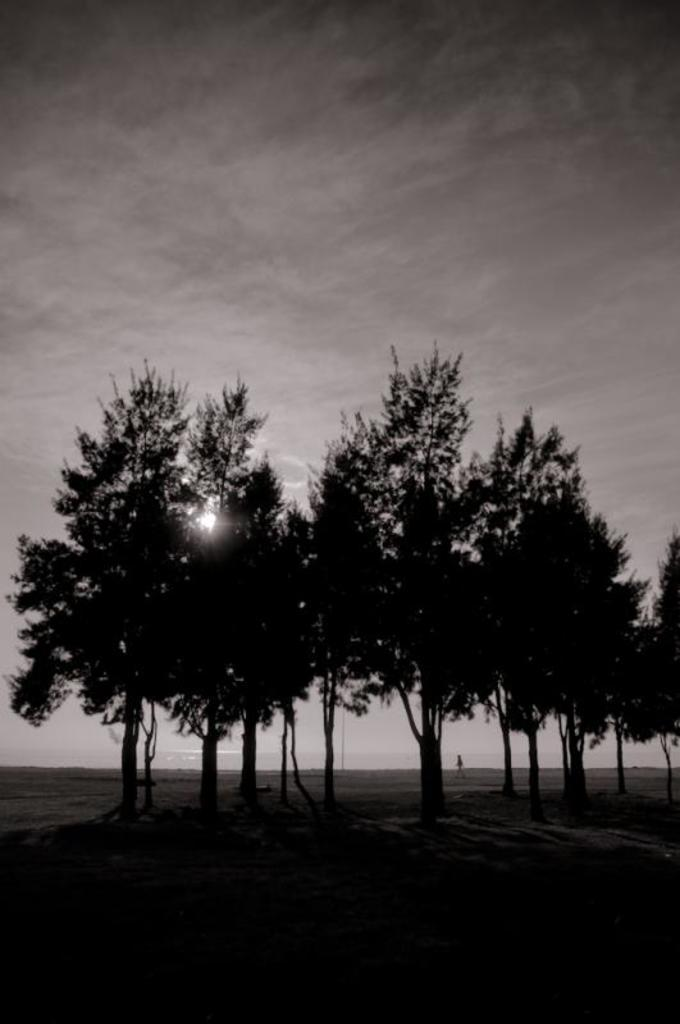What type of vegetation is present in the image? There are trees in the image. What part of the natural environment is visible in the image? The sky is visible at the top of the image. Can you describe the lighting conditions in the image? The image appears to be slightly dark. What type of apparel is the bee wearing in the image? There is no bee present in the image, so it is not possible to determine what type of apparel it might be wearing. 